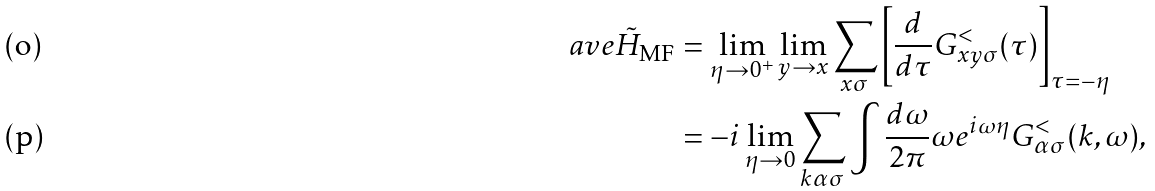<formula> <loc_0><loc_0><loc_500><loc_500>\ a v e { { \tilde { H } } _ { \text {MF} } } & = \lim _ { \eta \to 0 ^ { + } } \lim _ { y \to x } \sum _ { x \sigma } { \left [ \frac { d } { d \tau } G ^ { < } _ { x y \sigma } ( \tau ) \right ] } _ { \tau = - \eta } \\ & = - i \lim _ { \eta \to 0 } \sum _ { k \alpha \sigma } \int \frac { d \omega } { 2 \pi } \omega e ^ { i \omega \eta } G ^ { < } _ { \alpha \sigma } ( k , \omega ) ,</formula> 